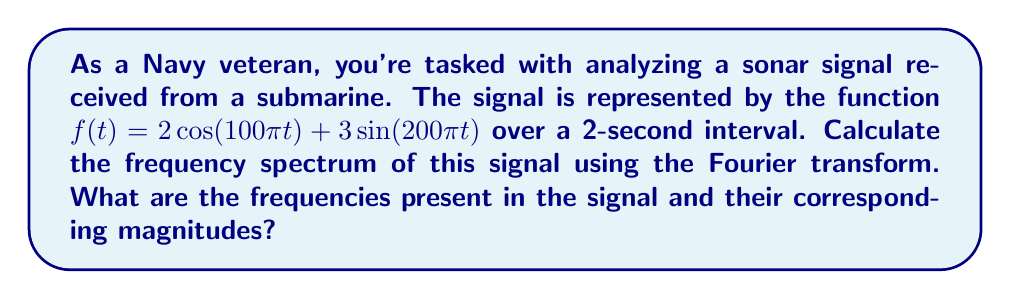Can you answer this question? Let's approach this step-by-step:

1) The Fourier transform of a continuous-time signal $f(t)$ is given by:

   $$F(\omega) = \int_{-\infty}^{\infty} f(t) e^{-j\omega t} dt$$

2) Our signal $f(t) = 2\cos(100\pi t) + 3\sin(200\pi t)$ consists of two components:
   - $2\cos(100\pi t)$
   - $3\sin(200\pi t)$

3) We can use the following Fourier transform pairs:
   - $\cos(\omega_0 t) \leftrightarrow \pi[\delta(\omega - \omega_0) + \delta(\omega + \omega_0)]$
   - $\sin(\omega_0 t) \leftrightarrow j\pi[\delta(\omega - \omega_0) - \delta(\omega + \omega_0)]$

4) For the cosine term:
   $2\cos(100\pi t) \leftrightarrow 2\pi[\delta(\omega - 100\pi) + \delta(\omega + 100\pi)]$

5) For the sine term:
   $3\sin(200\pi t) \leftrightarrow 3j\pi[\delta(\omega - 200\pi) - \delta(\omega + 200\pi)]$

6) The complete Fourier transform is the sum of these:
   $$F(\omega) = 2\pi[\delta(\omega - 100\pi) + \delta(\omega + 100\pi)] + 3j\pi[\delta(\omega - 200\pi) - \delta(\omega + 200\pi)]$$

7) The frequency spectrum is given by the magnitude of $F(\omega)$:
   $$|F(\omega)| = 2\pi[\delta(\omega - 100\pi) + \delta(\omega + 100\pi)] + 3\pi[\delta(\omega - 200\pi) + \delta(\omega + 200\pi)]$$

8) Converting from angular frequency $\omega$ to frequency $f$ (in Hz) using $\omega = 2\pi f$:
   - $\omega = 100\pi$ corresponds to $f = 50$ Hz
   - $\omega = 200\pi$ corresponds to $f = 100$ Hz

9) The magnitudes are:
   - For 50 Hz: $2\pi = 2\pi$
   - For 100 Hz: $3\pi$
Answer: Frequencies: 50 Hz and 100 Hz; Magnitudes: $2\pi$ and $3\pi$ respectively 